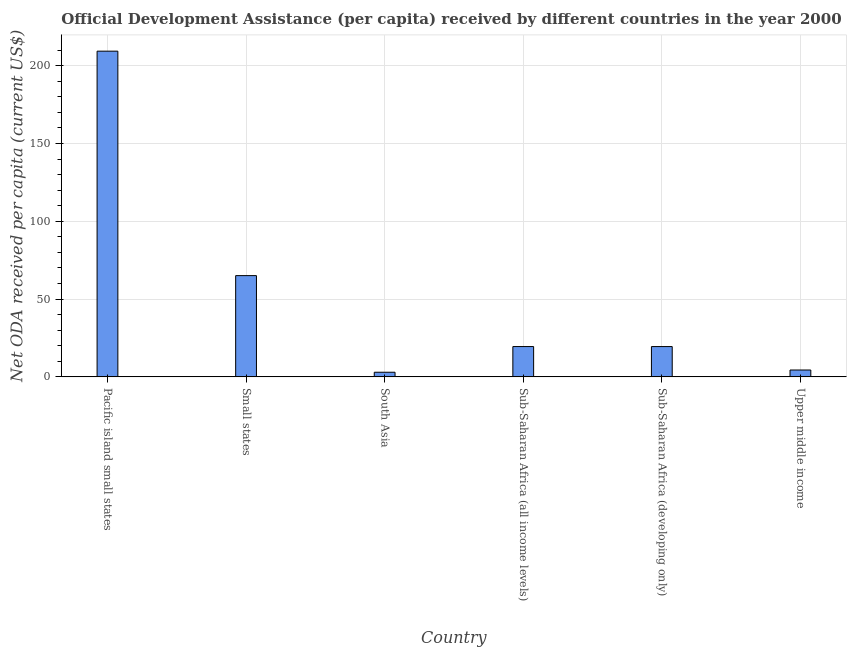Does the graph contain grids?
Your answer should be very brief. Yes. What is the title of the graph?
Provide a short and direct response. Official Development Assistance (per capita) received by different countries in the year 2000. What is the label or title of the Y-axis?
Give a very brief answer. Net ODA received per capita (current US$). What is the net oda received per capita in Sub-Saharan Africa (developing only)?
Offer a terse response. 19.47. Across all countries, what is the maximum net oda received per capita?
Your response must be concise. 209.31. Across all countries, what is the minimum net oda received per capita?
Your answer should be very brief. 2.97. In which country was the net oda received per capita maximum?
Your answer should be very brief. Pacific island small states. What is the sum of the net oda received per capita?
Provide a succinct answer. 320.7. What is the difference between the net oda received per capita in South Asia and Upper middle income?
Make the answer very short. -1.44. What is the average net oda received per capita per country?
Offer a very short reply. 53.45. What is the median net oda received per capita?
Make the answer very short. 19.48. What is the ratio of the net oda received per capita in Sub-Saharan Africa (all income levels) to that in Sub-Saharan Africa (developing only)?
Make the answer very short. 1. What is the difference between the highest and the second highest net oda received per capita?
Make the answer very short. 144.24. What is the difference between the highest and the lowest net oda received per capita?
Make the answer very short. 206.34. In how many countries, is the net oda received per capita greater than the average net oda received per capita taken over all countries?
Give a very brief answer. 2. How many countries are there in the graph?
Provide a short and direct response. 6. Are the values on the major ticks of Y-axis written in scientific E-notation?
Offer a terse response. No. What is the Net ODA received per capita (current US$) of Pacific island small states?
Provide a short and direct response. 209.31. What is the Net ODA received per capita (current US$) in Small states?
Provide a short and direct response. 65.07. What is the Net ODA received per capita (current US$) of South Asia?
Your response must be concise. 2.97. What is the Net ODA received per capita (current US$) in Sub-Saharan Africa (all income levels)?
Provide a succinct answer. 19.48. What is the Net ODA received per capita (current US$) in Sub-Saharan Africa (developing only)?
Keep it short and to the point. 19.47. What is the Net ODA received per capita (current US$) in Upper middle income?
Offer a very short reply. 4.41. What is the difference between the Net ODA received per capita (current US$) in Pacific island small states and Small states?
Offer a terse response. 144.24. What is the difference between the Net ODA received per capita (current US$) in Pacific island small states and South Asia?
Provide a succinct answer. 206.34. What is the difference between the Net ODA received per capita (current US$) in Pacific island small states and Sub-Saharan Africa (all income levels)?
Provide a short and direct response. 189.82. What is the difference between the Net ODA received per capita (current US$) in Pacific island small states and Sub-Saharan Africa (developing only)?
Keep it short and to the point. 189.84. What is the difference between the Net ODA received per capita (current US$) in Pacific island small states and Upper middle income?
Give a very brief answer. 204.9. What is the difference between the Net ODA received per capita (current US$) in Small states and South Asia?
Ensure brevity in your answer.  62.1. What is the difference between the Net ODA received per capita (current US$) in Small states and Sub-Saharan Africa (all income levels)?
Your answer should be compact. 45.58. What is the difference between the Net ODA received per capita (current US$) in Small states and Sub-Saharan Africa (developing only)?
Your answer should be very brief. 45.6. What is the difference between the Net ODA received per capita (current US$) in Small states and Upper middle income?
Your answer should be compact. 60.66. What is the difference between the Net ODA received per capita (current US$) in South Asia and Sub-Saharan Africa (all income levels)?
Give a very brief answer. -16.51. What is the difference between the Net ODA received per capita (current US$) in South Asia and Sub-Saharan Africa (developing only)?
Provide a succinct answer. -16.5. What is the difference between the Net ODA received per capita (current US$) in South Asia and Upper middle income?
Your answer should be compact. -1.44. What is the difference between the Net ODA received per capita (current US$) in Sub-Saharan Africa (all income levels) and Sub-Saharan Africa (developing only)?
Provide a short and direct response. 0.01. What is the difference between the Net ODA received per capita (current US$) in Sub-Saharan Africa (all income levels) and Upper middle income?
Ensure brevity in your answer.  15.08. What is the difference between the Net ODA received per capita (current US$) in Sub-Saharan Africa (developing only) and Upper middle income?
Your response must be concise. 15.06. What is the ratio of the Net ODA received per capita (current US$) in Pacific island small states to that in Small states?
Your answer should be very brief. 3.22. What is the ratio of the Net ODA received per capita (current US$) in Pacific island small states to that in South Asia?
Provide a short and direct response. 70.47. What is the ratio of the Net ODA received per capita (current US$) in Pacific island small states to that in Sub-Saharan Africa (all income levels)?
Give a very brief answer. 10.74. What is the ratio of the Net ODA received per capita (current US$) in Pacific island small states to that in Sub-Saharan Africa (developing only)?
Provide a succinct answer. 10.75. What is the ratio of the Net ODA received per capita (current US$) in Pacific island small states to that in Upper middle income?
Your answer should be very brief. 47.51. What is the ratio of the Net ODA received per capita (current US$) in Small states to that in South Asia?
Make the answer very short. 21.91. What is the ratio of the Net ODA received per capita (current US$) in Small states to that in Sub-Saharan Africa (all income levels)?
Make the answer very short. 3.34. What is the ratio of the Net ODA received per capita (current US$) in Small states to that in Sub-Saharan Africa (developing only)?
Provide a short and direct response. 3.34. What is the ratio of the Net ODA received per capita (current US$) in Small states to that in Upper middle income?
Your answer should be very brief. 14.77. What is the ratio of the Net ODA received per capita (current US$) in South Asia to that in Sub-Saharan Africa (all income levels)?
Keep it short and to the point. 0.15. What is the ratio of the Net ODA received per capita (current US$) in South Asia to that in Sub-Saharan Africa (developing only)?
Provide a succinct answer. 0.15. What is the ratio of the Net ODA received per capita (current US$) in South Asia to that in Upper middle income?
Offer a terse response. 0.67. What is the ratio of the Net ODA received per capita (current US$) in Sub-Saharan Africa (all income levels) to that in Sub-Saharan Africa (developing only)?
Offer a terse response. 1. What is the ratio of the Net ODA received per capita (current US$) in Sub-Saharan Africa (all income levels) to that in Upper middle income?
Offer a terse response. 4.42. What is the ratio of the Net ODA received per capita (current US$) in Sub-Saharan Africa (developing only) to that in Upper middle income?
Give a very brief answer. 4.42. 